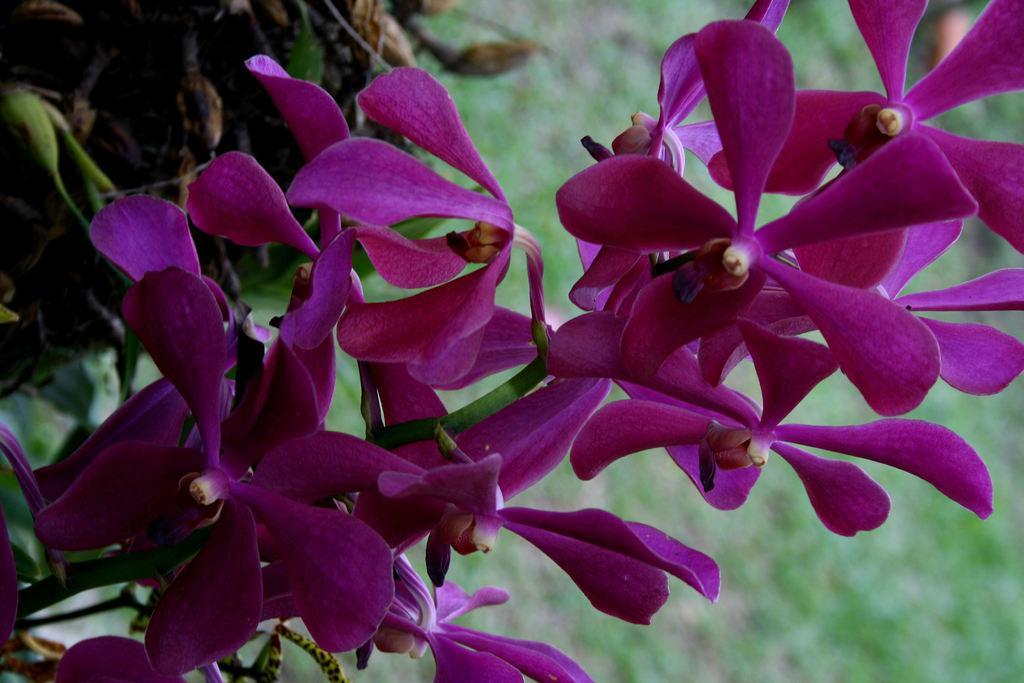Can you describe this image briefly? In the picture we can see some pink color flowers to the stem and behind it, we can see some plants which are not clearly visible. 